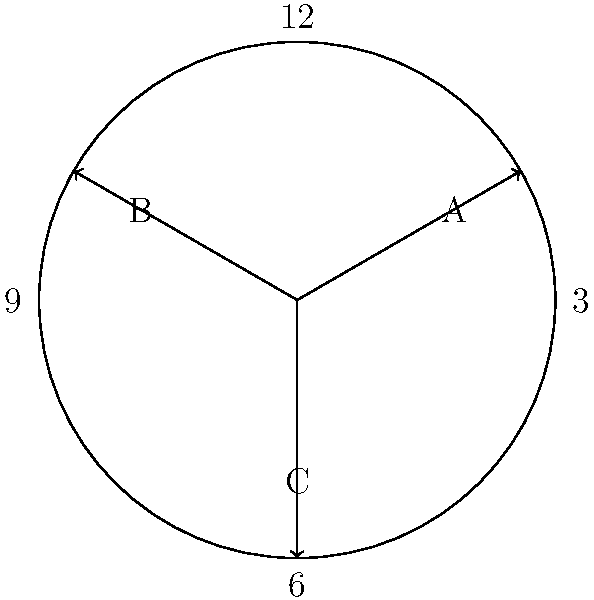In the diagram above, which represents a watch face, three arrows (A, B, and C) are shown. What time does this watch display? To determine the time displayed by the watch, we need to follow these steps:

1. Identify the hour hand:
   - The shortest arrow is typically the hour hand.
   - In this case, arrow A is the shortest, pointing between 1 and 2.

2. Identify the minute hand:
   - The second-longest arrow is usually the minute hand.
   - Arrow B is the second-longest, pointing at 5.

3. Identify the second hand:
   - The longest and thinnest arrow is typically the second hand.
   - Arrow C is the longest, pointing at 9.

4. Read the hour:
   - Arrow A is pointing just past 1, indicating it's between 1 and 2 o'clock.

5. Read the minutes:
   - Arrow B is pointing exactly at 5, which represents 25 minutes past the hour.

6. Combine the readings:
   - The time shown is 1:25 (and 45 seconds, but we typically round to the nearest minute for analog watches).

Therefore, the watch displays 1:25.
Answer: 1:25 